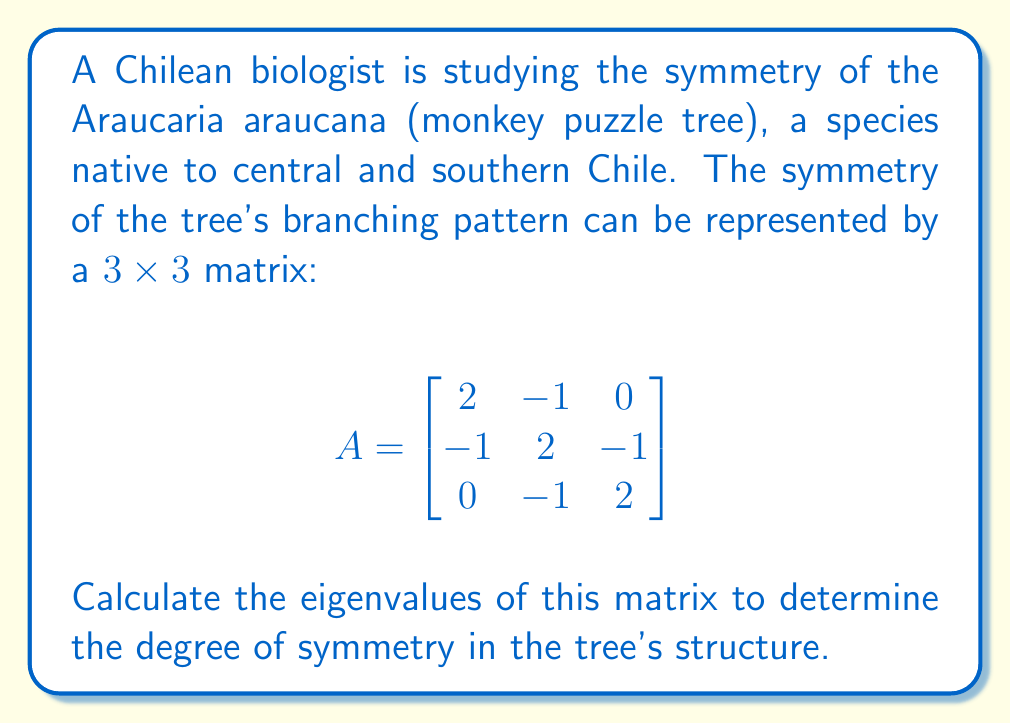Can you answer this question? To find the eigenvalues, we need to solve the characteristic equation:

1) First, we set up the equation $\det(A - \lambda I) = 0$, where $\lambda$ represents the eigenvalues:

   $$\det\begin{pmatrix}
   2-\lambda & -1 & 0 \\
   -1 & 2-\lambda & -1 \\
   0 & -1 & 2-\lambda
   \end{pmatrix} = 0$$

2) Expand the determinant:
   $$(2-\lambda)[(2-\lambda)(2-\lambda) - 1] - (-1)[(-1)(2-\lambda) - 0] = 0$$

3) Simplify:
   $$(2-\lambda)[(2-\lambda)^2 - 1] + (2-\lambda) = 0$$
   $$(2-\lambda)[(2-\lambda)^2 - 1 + 1] = 0$$
   $$(2-\lambda)(2-\lambda)^2 = 0$$

4) Factor the equation:
   $(2-\lambda)(2-\lambda+1)(2-\lambda-1) = 0$
   $(2-\lambda)(3-\lambda)(1-\lambda) = 0$

5) Solve for $\lambda$:
   $\lambda = 2$ or $\lambda = 3$ or $\lambda = 1$

Therefore, the eigenvalues are 1, 2, and 3.
Answer: $\lambda = 1, 2, 3$ 